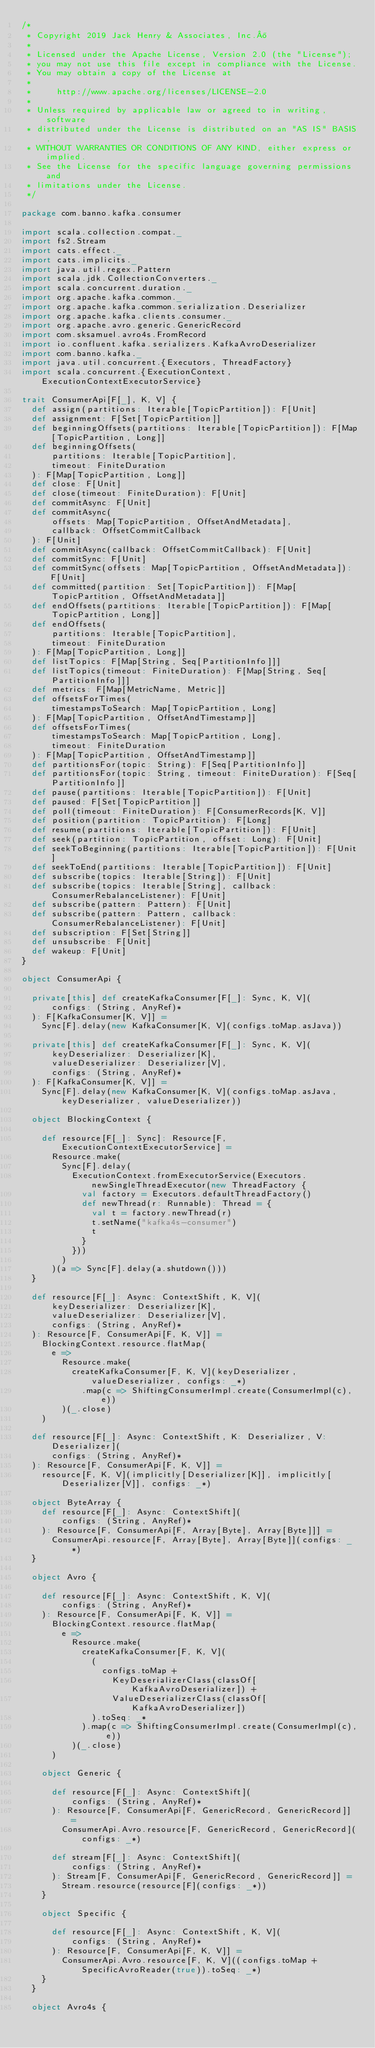<code> <loc_0><loc_0><loc_500><loc_500><_Scala_>/*
 * Copyright 2019 Jack Henry & Associates, Inc.®
 *
 * Licensed under the Apache License, Version 2.0 (the "License");
 * you may not use this file except in compliance with the License.
 * You may obtain a copy of the License at
 *
 *     http://www.apache.org/licenses/LICENSE-2.0
 *
 * Unless required by applicable law or agreed to in writing, software
 * distributed under the License is distributed on an "AS IS" BASIS,
 * WITHOUT WARRANTIES OR CONDITIONS OF ANY KIND, either express or implied.
 * See the License for the specific language governing permissions and
 * limitations under the License.
 */

package com.banno.kafka.consumer

import scala.collection.compat._
import fs2.Stream
import cats.effect._
import cats.implicits._
import java.util.regex.Pattern
import scala.jdk.CollectionConverters._
import scala.concurrent.duration._
import org.apache.kafka.common._
import org.apache.kafka.common.serialization.Deserializer
import org.apache.kafka.clients.consumer._
import org.apache.avro.generic.GenericRecord
import com.sksamuel.avro4s.FromRecord
import io.confluent.kafka.serializers.KafkaAvroDeserializer
import com.banno.kafka._
import java.util.concurrent.{Executors, ThreadFactory}
import scala.concurrent.{ExecutionContext, ExecutionContextExecutorService}

trait ConsumerApi[F[_], K, V] {
  def assign(partitions: Iterable[TopicPartition]): F[Unit]
  def assignment: F[Set[TopicPartition]]
  def beginningOffsets(partitions: Iterable[TopicPartition]): F[Map[TopicPartition, Long]]
  def beginningOffsets(
      partitions: Iterable[TopicPartition],
      timeout: FiniteDuration
  ): F[Map[TopicPartition, Long]]
  def close: F[Unit]
  def close(timeout: FiniteDuration): F[Unit]
  def commitAsync: F[Unit]
  def commitAsync(
      offsets: Map[TopicPartition, OffsetAndMetadata],
      callback: OffsetCommitCallback
  ): F[Unit]
  def commitAsync(callback: OffsetCommitCallback): F[Unit]
  def commitSync: F[Unit]
  def commitSync(offsets: Map[TopicPartition, OffsetAndMetadata]): F[Unit]
  def committed(partition: Set[TopicPartition]): F[Map[TopicPartition, OffsetAndMetadata]]
  def endOffsets(partitions: Iterable[TopicPartition]): F[Map[TopicPartition, Long]]
  def endOffsets(
      partitions: Iterable[TopicPartition],
      timeout: FiniteDuration
  ): F[Map[TopicPartition, Long]]
  def listTopics: F[Map[String, Seq[PartitionInfo]]]
  def listTopics(timeout: FiniteDuration): F[Map[String, Seq[PartitionInfo]]]
  def metrics: F[Map[MetricName, Metric]]
  def offsetsForTimes(
      timestampsToSearch: Map[TopicPartition, Long]
  ): F[Map[TopicPartition, OffsetAndTimestamp]]
  def offsetsForTimes(
      timestampsToSearch: Map[TopicPartition, Long],
      timeout: FiniteDuration
  ): F[Map[TopicPartition, OffsetAndTimestamp]]
  def partitionsFor(topic: String): F[Seq[PartitionInfo]]
  def partitionsFor(topic: String, timeout: FiniteDuration): F[Seq[PartitionInfo]]
  def pause(partitions: Iterable[TopicPartition]): F[Unit]
  def paused: F[Set[TopicPartition]]
  def poll(timeout: FiniteDuration): F[ConsumerRecords[K, V]]
  def position(partition: TopicPartition): F[Long]
  def resume(partitions: Iterable[TopicPartition]): F[Unit]
  def seek(partition: TopicPartition, offset: Long): F[Unit]
  def seekToBeginning(partitions: Iterable[TopicPartition]): F[Unit]
  def seekToEnd(partitions: Iterable[TopicPartition]): F[Unit]
  def subscribe(topics: Iterable[String]): F[Unit]
  def subscribe(topics: Iterable[String], callback: ConsumerRebalanceListener): F[Unit]
  def subscribe(pattern: Pattern): F[Unit]
  def subscribe(pattern: Pattern, callback: ConsumerRebalanceListener): F[Unit]
  def subscription: F[Set[String]]
  def unsubscribe: F[Unit]
  def wakeup: F[Unit]
}

object ConsumerApi {

  private[this] def createKafkaConsumer[F[_]: Sync, K, V](
      configs: (String, AnyRef)*
  ): F[KafkaConsumer[K, V]] =
    Sync[F].delay(new KafkaConsumer[K, V](configs.toMap.asJava))

  private[this] def createKafkaConsumer[F[_]: Sync, K, V](
      keyDeserializer: Deserializer[K],
      valueDeserializer: Deserializer[V],
      configs: (String, AnyRef)*
  ): F[KafkaConsumer[K, V]] =
    Sync[F].delay(new KafkaConsumer[K, V](configs.toMap.asJava, keyDeserializer, valueDeserializer))

  object BlockingContext {

    def resource[F[_]: Sync]: Resource[F, ExecutionContextExecutorService] =
      Resource.make(
        Sync[F].delay(
          ExecutionContext.fromExecutorService(Executors.newSingleThreadExecutor(new ThreadFactory {
            val factory = Executors.defaultThreadFactory()
            def newThread(r: Runnable): Thread = {
              val t = factory.newThread(r)
              t.setName("kafka4s-consumer")
              t
            }
          }))
        )
      )(a => Sync[F].delay(a.shutdown()))
  }

  def resource[F[_]: Async: ContextShift, K, V](
      keyDeserializer: Deserializer[K],
      valueDeserializer: Deserializer[V],
      configs: (String, AnyRef)*
  ): Resource[F, ConsumerApi[F, K, V]] =
    BlockingContext.resource.flatMap(
      e =>
        Resource.make(
          createKafkaConsumer[F, K, V](keyDeserializer, valueDeserializer, configs: _*)
            .map(c => ShiftingConsumerImpl.create(ConsumerImpl(c), e))
        )(_.close)
    )

  def resource[F[_]: Async: ContextShift, K: Deserializer, V: Deserializer](
      configs: (String, AnyRef)*
  ): Resource[F, ConsumerApi[F, K, V]] =
    resource[F, K, V](implicitly[Deserializer[K]], implicitly[Deserializer[V]], configs: _*)

  object ByteArray {
    def resource[F[_]: Async: ContextShift](
        configs: (String, AnyRef)*
    ): Resource[F, ConsumerApi[F, Array[Byte], Array[Byte]]] =
      ConsumerApi.resource[F, Array[Byte], Array[Byte]](configs: _*)
  }

  object Avro {

    def resource[F[_]: Async: ContextShift, K, V](
        configs: (String, AnyRef)*
    ): Resource[F, ConsumerApi[F, K, V]] =
      BlockingContext.resource.flatMap(
        e =>
          Resource.make(
            createKafkaConsumer[F, K, V](
              (
                configs.toMap +
                  KeyDeserializerClass(classOf[KafkaAvroDeserializer]) +
                  ValueDeserializerClass(classOf[KafkaAvroDeserializer])
              ).toSeq: _*
            ).map(c => ShiftingConsumerImpl.create(ConsumerImpl(c), e))
          )(_.close)
      )

    object Generic {

      def resource[F[_]: Async: ContextShift](
          configs: (String, AnyRef)*
      ): Resource[F, ConsumerApi[F, GenericRecord, GenericRecord]] =
        ConsumerApi.Avro.resource[F, GenericRecord, GenericRecord](configs: _*)

      def stream[F[_]: Async: ContextShift](
          configs: (String, AnyRef)*
      ): Stream[F, ConsumerApi[F, GenericRecord, GenericRecord]] =
        Stream.resource(resource[F](configs: _*))
    }

    object Specific {

      def resource[F[_]: Async: ContextShift, K, V](
          configs: (String, AnyRef)*
      ): Resource[F, ConsumerApi[F, K, V]] =
        ConsumerApi.Avro.resource[F, K, V]((configs.toMap + SpecificAvroReader(true)).toSeq: _*)
    }
  }

  object Avro4s {
</code> 